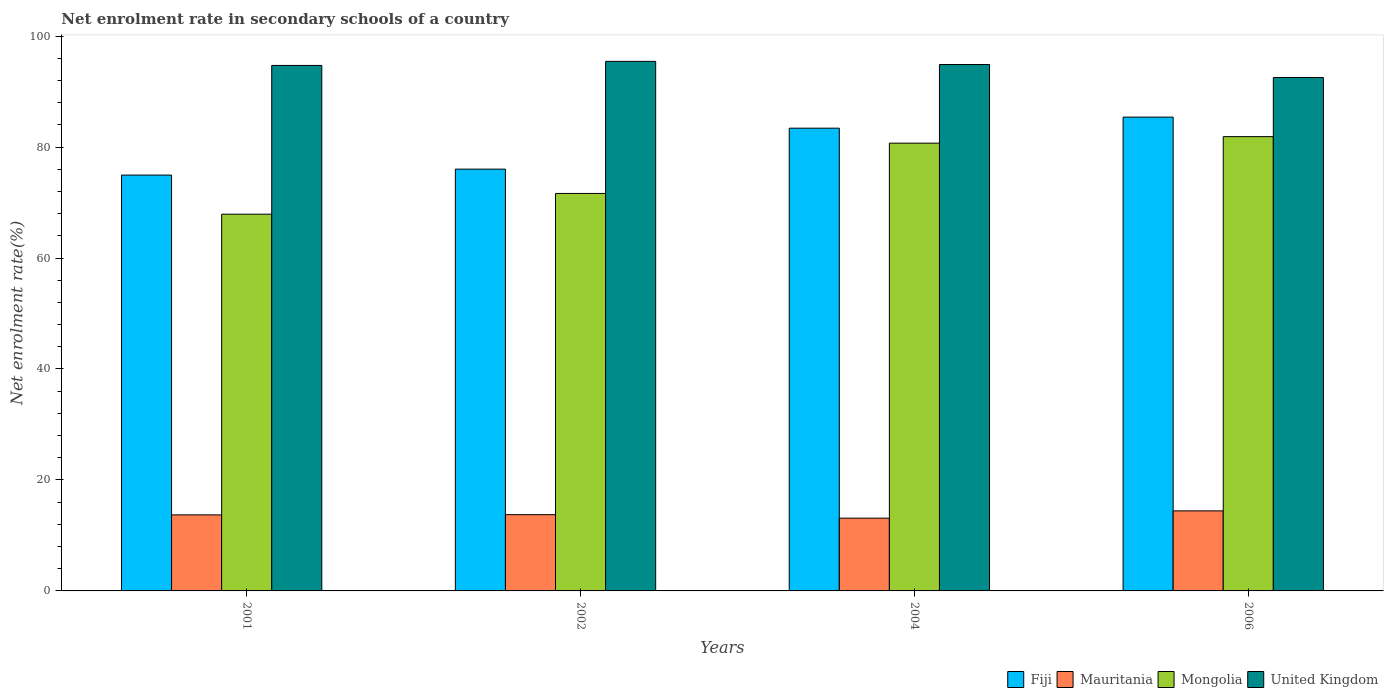How many different coloured bars are there?
Ensure brevity in your answer.  4. How many groups of bars are there?
Give a very brief answer. 4. Are the number of bars per tick equal to the number of legend labels?
Provide a short and direct response. Yes. Are the number of bars on each tick of the X-axis equal?
Provide a short and direct response. Yes. How many bars are there on the 1st tick from the left?
Your response must be concise. 4. How many bars are there on the 1st tick from the right?
Keep it short and to the point. 4. What is the label of the 3rd group of bars from the left?
Keep it short and to the point. 2004. In how many cases, is the number of bars for a given year not equal to the number of legend labels?
Give a very brief answer. 0. What is the net enrolment rate in secondary schools in Mauritania in 2002?
Your answer should be very brief. 13.75. Across all years, what is the maximum net enrolment rate in secondary schools in Mongolia?
Give a very brief answer. 81.88. Across all years, what is the minimum net enrolment rate in secondary schools in United Kingdom?
Ensure brevity in your answer.  92.54. In which year was the net enrolment rate in secondary schools in United Kingdom maximum?
Provide a succinct answer. 2002. What is the total net enrolment rate in secondary schools in Fiji in the graph?
Offer a very short reply. 319.78. What is the difference between the net enrolment rate in secondary schools in Mauritania in 2002 and that in 2006?
Give a very brief answer. -0.68. What is the difference between the net enrolment rate in secondary schools in Mongolia in 2006 and the net enrolment rate in secondary schools in Mauritania in 2004?
Offer a terse response. 68.77. What is the average net enrolment rate in secondary schools in Fiji per year?
Ensure brevity in your answer.  79.95. In the year 2001, what is the difference between the net enrolment rate in secondary schools in Mauritania and net enrolment rate in secondary schools in Mongolia?
Offer a terse response. -54.2. What is the ratio of the net enrolment rate in secondary schools in Fiji in 2001 to that in 2006?
Your answer should be very brief. 0.88. Is the net enrolment rate in secondary schools in Mauritania in 2004 less than that in 2006?
Make the answer very short. Yes. What is the difference between the highest and the second highest net enrolment rate in secondary schools in Fiji?
Make the answer very short. 1.99. What is the difference between the highest and the lowest net enrolment rate in secondary schools in United Kingdom?
Provide a short and direct response. 2.91. Is the sum of the net enrolment rate in secondary schools in Fiji in 2001 and 2006 greater than the maximum net enrolment rate in secondary schools in Mauritania across all years?
Keep it short and to the point. Yes. What does the 1st bar from the left in 2002 represents?
Offer a terse response. Fiji. What does the 3rd bar from the right in 2002 represents?
Ensure brevity in your answer.  Mauritania. Is it the case that in every year, the sum of the net enrolment rate in secondary schools in Mauritania and net enrolment rate in secondary schools in United Kingdom is greater than the net enrolment rate in secondary schools in Fiji?
Keep it short and to the point. Yes. How many bars are there?
Offer a very short reply. 16. Where does the legend appear in the graph?
Your response must be concise. Bottom right. How many legend labels are there?
Provide a succinct answer. 4. How are the legend labels stacked?
Keep it short and to the point. Horizontal. What is the title of the graph?
Provide a short and direct response. Net enrolment rate in secondary schools of a country. What is the label or title of the X-axis?
Keep it short and to the point. Years. What is the label or title of the Y-axis?
Provide a short and direct response. Net enrolment rate(%). What is the Net enrolment rate(%) of Fiji in 2001?
Offer a very short reply. 74.95. What is the Net enrolment rate(%) of Mauritania in 2001?
Provide a succinct answer. 13.71. What is the Net enrolment rate(%) in Mongolia in 2001?
Offer a very short reply. 67.9. What is the Net enrolment rate(%) of United Kingdom in 2001?
Your response must be concise. 94.72. What is the Net enrolment rate(%) of Fiji in 2002?
Your answer should be very brief. 76.02. What is the Net enrolment rate(%) in Mauritania in 2002?
Give a very brief answer. 13.75. What is the Net enrolment rate(%) in Mongolia in 2002?
Give a very brief answer. 71.64. What is the Net enrolment rate(%) in United Kingdom in 2002?
Keep it short and to the point. 95.45. What is the Net enrolment rate(%) of Fiji in 2004?
Offer a terse response. 83.41. What is the Net enrolment rate(%) of Mauritania in 2004?
Your answer should be compact. 13.11. What is the Net enrolment rate(%) in Mongolia in 2004?
Offer a very short reply. 80.71. What is the Net enrolment rate(%) of United Kingdom in 2004?
Keep it short and to the point. 94.88. What is the Net enrolment rate(%) in Fiji in 2006?
Your response must be concise. 85.4. What is the Net enrolment rate(%) in Mauritania in 2006?
Offer a very short reply. 14.43. What is the Net enrolment rate(%) in Mongolia in 2006?
Make the answer very short. 81.88. What is the Net enrolment rate(%) of United Kingdom in 2006?
Provide a short and direct response. 92.54. Across all years, what is the maximum Net enrolment rate(%) in Fiji?
Provide a short and direct response. 85.4. Across all years, what is the maximum Net enrolment rate(%) of Mauritania?
Offer a very short reply. 14.43. Across all years, what is the maximum Net enrolment rate(%) of Mongolia?
Give a very brief answer. 81.88. Across all years, what is the maximum Net enrolment rate(%) in United Kingdom?
Keep it short and to the point. 95.45. Across all years, what is the minimum Net enrolment rate(%) in Fiji?
Your response must be concise. 74.95. Across all years, what is the minimum Net enrolment rate(%) of Mauritania?
Offer a terse response. 13.11. Across all years, what is the minimum Net enrolment rate(%) in Mongolia?
Your answer should be very brief. 67.9. Across all years, what is the minimum Net enrolment rate(%) in United Kingdom?
Your response must be concise. 92.54. What is the total Net enrolment rate(%) in Fiji in the graph?
Offer a very short reply. 319.78. What is the total Net enrolment rate(%) in Mauritania in the graph?
Make the answer very short. 55. What is the total Net enrolment rate(%) of Mongolia in the graph?
Provide a short and direct response. 302.13. What is the total Net enrolment rate(%) in United Kingdom in the graph?
Give a very brief answer. 377.59. What is the difference between the Net enrolment rate(%) of Fiji in 2001 and that in 2002?
Offer a terse response. -1.07. What is the difference between the Net enrolment rate(%) in Mauritania in 2001 and that in 2002?
Provide a succinct answer. -0.04. What is the difference between the Net enrolment rate(%) in Mongolia in 2001 and that in 2002?
Ensure brevity in your answer.  -3.74. What is the difference between the Net enrolment rate(%) in United Kingdom in 2001 and that in 2002?
Your answer should be very brief. -0.73. What is the difference between the Net enrolment rate(%) of Fiji in 2001 and that in 2004?
Your answer should be compact. -8.46. What is the difference between the Net enrolment rate(%) in Mauritania in 2001 and that in 2004?
Offer a very short reply. 0.59. What is the difference between the Net enrolment rate(%) in Mongolia in 2001 and that in 2004?
Make the answer very short. -12.8. What is the difference between the Net enrolment rate(%) in United Kingdom in 2001 and that in 2004?
Provide a short and direct response. -0.17. What is the difference between the Net enrolment rate(%) in Fiji in 2001 and that in 2006?
Provide a short and direct response. -10.45. What is the difference between the Net enrolment rate(%) in Mauritania in 2001 and that in 2006?
Your answer should be compact. -0.72. What is the difference between the Net enrolment rate(%) in Mongolia in 2001 and that in 2006?
Provide a succinct answer. -13.98. What is the difference between the Net enrolment rate(%) of United Kingdom in 2001 and that in 2006?
Ensure brevity in your answer.  2.18. What is the difference between the Net enrolment rate(%) of Fiji in 2002 and that in 2004?
Offer a terse response. -7.38. What is the difference between the Net enrolment rate(%) in Mauritania in 2002 and that in 2004?
Your answer should be compact. 0.63. What is the difference between the Net enrolment rate(%) of Mongolia in 2002 and that in 2004?
Keep it short and to the point. -9.07. What is the difference between the Net enrolment rate(%) of United Kingdom in 2002 and that in 2004?
Provide a short and direct response. 0.57. What is the difference between the Net enrolment rate(%) of Fiji in 2002 and that in 2006?
Give a very brief answer. -9.38. What is the difference between the Net enrolment rate(%) of Mauritania in 2002 and that in 2006?
Make the answer very short. -0.68. What is the difference between the Net enrolment rate(%) in Mongolia in 2002 and that in 2006?
Keep it short and to the point. -10.24. What is the difference between the Net enrolment rate(%) in United Kingdom in 2002 and that in 2006?
Your response must be concise. 2.91. What is the difference between the Net enrolment rate(%) in Fiji in 2004 and that in 2006?
Ensure brevity in your answer.  -1.99. What is the difference between the Net enrolment rate(%) in Mauritania in 2004 and that in 2006?
Your response must be concise. -1.32. What is the difference between the Net enrolment rate(%) in Mongolia in 2004 and that in 2006?
Your response must be concise. -1.17. What is the difference between the Net enrolment rate(%) of United Kingdom in 2004 and that in 2006?
Offer a very short reply. 2.35. What is the difference between the Net enrolment rate(%) in Fiji in 2001 and the Net enrolment rate(%) in Mauritania in 2002?
Your response must be concise. 61.2. What is the difference between the Net enrolment rate(%) in Fiji in 2001 and the Net enrolment rate(%) in Mongolia in 2002?
Your answer should be very brief. 3.31. What is the difference between the Net enrolment rate(%) in Fiji in 2001 and the Net enrolment rate(%) in United Kingdom in 2002?
Give a very brief answer. -20.5. What is the difference between the Net enrolment rate(%) of Mauritania in 2001 and the Net enrolment rate(%) of Mongolia in 2002?
Ensure brevity in your answer.  -57.93. What is the difference between the Net enrolment rate(%) of Mauritania in 2001 and the Net enrolment rate(%) of United Kingdom in 2002?
Keep it short and to the point. -81.74. What is the difference between the Net enrolment rate(%) in Mongolia in 2001 and the Net enrolment rate(%) in United Kingdom in 2002?
Provide a short and direct response. -27.55. What is the difference between the Net enrolment rate(%) of Fiji in 2001 and the Net enrolment rate(%) of Mauritania in 2004?
Make the answer very short. 61.84. What is the difference between the Net enrolment rate(%) of Fiji in 2001 and the Net enrolment rate(%) of Mongolia in 2004?
Provide a short and direct response. -5.76. What is the difference between the Net enrolment rate(%) of Fiji in 2001 and the Net enrolment rate(%) of United Kingdom in 2004?
Your answer should be very brief. -19.93. What is the difference between the Net enrolment rate(%) of Mauritania in 2001 and the Net enrolment rate(%) of Mongolia in 2004?
Your response must be concise. -67. What is the difference between the Net enrolment rate(%) of Mauritania in 2001 and the Net enrolment rate(%) of United Kingdom in 2004?
Keep it short and to the point. -81.18. What is the difference between the Net enrolment rate(%) in Mongolia in 2001 and the Net enrolment rate(%) in United Kingdom in 2004?
Your answer should be very brief. -26.98. What is the difference between the Net enrolment rate(%) of Fiji in 2001 and the Net enrolment rate(%) of Mauritania in 2006?
Your answer should be compact. 60.52. What is the difference between the Net enrolment rate(%) of Fiji in 2001 and the Net enrolment rate(%) of Mongolia in 2006?
Offer a very short reply. -6.93. What is the difference between the Net enrolment rate(%) in Fiji in 2001 and the Net enrolment rate(%) in United Kingdom in 2006?
Your answer should be very brief. -17.59. What is the difference between the Net enrolment rate(%) of Mauritania in 2001 and the Net enrolment rate(%) of Mongolia in 2006?
Provide a short and direct response. -68.17. What is the difference between the Net enrolment rate(%) of Mauritania in 2001 and the Net enrolment rate(%) of United Kingdom in 2006?
Keep it short and to the point. -78.83. What is the difference between the Net enrolment rate(%) in Mongolia in 2001 and the Net enrolment rate(%) in United Kingdom in 2006?
Your answer should be compact. -24.63. What is the difference between the Net enrolment rate(%) of Fiji in 2002 and the Net enrolment rate(%) of Mauritania in 2004?
Give a very brief answer. 62.91. What is the difference between the Net enrolment rate(%) in Fiji in 2002 and the Net enrolment rate(%) in Mongolia in 2004?
Make the answer very short. -4.68. What is the difference between the Net enrolment rate(%) of Fiji in 2002 and the Net enrolment rate(%) of United Kingdom in 2004?
Ensure brevity in your answer.  -18.86. What is the difference between the Net enrolment rate(%) of Mauritania in 2002 and the Net enrolment rate(%) of Mongolia in 2004?
Ensure brevity in your answer.  -66.96. What is the difference between the Net enrolment rate(%) of Mauritania in 2002 and the Net enrolment rate(%) of United Kingdom in 2004?
Provide a succinct answer. -81.14. What is the difference between the Net enrolment rate(%) in Mongolia in 2002 and the Net enrolment rate(%) in United Kingdom in 2004?
Offer a terse response. -23.24. What is the difference between the Net enrolment rate(%) in Fiji in 2002 and the Net enrolment rate(%) in Mauritania in 2006?
Make the answer very short. 61.59. What is the difference between the Net enrolment rate(%) of Fiji in 2002 and the Net enrolment rate(%) of Mongolia in 2006?
Your answer should be very brief. -5.86. What is the difference between the Net enrolment rate(%) of Fiji in 2002 and the Net enrolment rate(%) of United Kingdom in 2006?
Keep it short and to the point. -16.51. What is the difference between the Net enrolment rate(%) in Mauritania in 2002 and the Net enrolment rate(%) in Mongolia in 2006?
Your response must be concise. -68.13. What is the difference between the Net enrolment rate(%) in Mauritania in 2002 and the Net enrolment rate(%) in United Kingdom in 2006?
Offer a very short reply. -78.79. What is the difference between the Net enrolment rate(%) of Mongolia in 2002 and the Net enrolment rate(%) of United Kingdom in 2006?
Ensure brevity in your answer.  -20.9. What is the difference between the Net enrolment rate(%) in Fiji in 2004 and the Net enrolment rate(%) in Mauritania in 2006?
Provide a short and direct response. 68.98. What is the difference between the Net enrolment rate(%) of Fiji in 2004 and the Net enrolment rate(%) of Mongolia in 2006?
Provide a short and direct response. 1.53. What is the difference between the Net enrolment rate(%) of Fiji in 2004 and the Net enrolment rate(%) of United Kingdom in 2006?
Ensure brevity in your answer.  -9.13. What is the difference between the Net enrolment rate(%) in Mauritania in 2004 and the Net enrolment rate(%) in Mongolia in 2006?
Provide a succinct answer. -68.77. What is the difference between the Net enrolment rate(%) of Mauritania in 2004 and the Net enrolment rate(%) of United Kingdom in 2006?
Offer a terse response. -79.42. What is the difference between the Net enrolment rate(%) of Mongolia in 2004 and the Net enrolment rate(%) of United Kingdom in 2006?
Ensure brevity in your answer.  -11.83. What is the average Net enrolment rate(%) in Fiji per year?
Provide a succinct answer. 79.95. What is the average Net enrolment rate(%) of Mauritania per year?
Offer a terse response. 13.75. What is the average Net enrolment rate(%) of Mongolia per year?
Ensure brevity in your answer.  75.53. What is the average Net enrolment rate(%) of United Kingdom per year?
Offer a very short reply. 94.4. In the year 2001, what is the difference between the Net enrolment rate(%) of Fiji and Net enrolment rate(%) of Mauritania?
Keep it short and to the point. 61.24. In the year 2001, what is the difference between the Net enrolment rate(%) of Fiji and Net enrolment rate(%) of Mongolia?
Provide a short and direct response. 7.05. In the year 2001, what is the difference between the Net enrolment rate(%) in Fiji and Net enrolment rate(%) in United Kingdom?
Your answer should be compact. -19.77. In the year 2001, what is the difference between the Net enrolment rate(%) in Mauritania and Net enrolment rate(%) in Mongolia?
Your answer should be compact. -54.2. In the year 2001, what is the difference between the Net enrolment rate(%) of Mauritania and Net enrolment rate(%) of United Kingdom?
Ensure brevity in your answer.  -81.01. In the year 2001, what is the difference between the Net enrolment rate(%) of Mongolia and Net enrolment rate(%) of United Kingdom?
Offer a terse response. -26.81. In the year 2002, what is the difference between the Net enrolment rate(%) in Fiji and Net enrolment rate(%) in Mauritania?
Your response must be concise. 62.28. In the year 2002, what is the difference between the Net enrolment rate(%) in Fiji and Net enrolment rate(%) in Mongolia?
Keep it short and to the point. 4.38. In the year 2002, what is the difference between the Net enrolment rate(%) in Fiji and Net enrolment rate(%) in United Kingdom?
Offer a very short reply. -19.43. In the year 2002, what is the difference between the Net enrolment rate(%) in Mauritania and Net enrolment rate(%) in Mongolia?
Provide a succinct answer. -57.9. In the year 2002, what is the difference between the Net enrolment rate(%) in Mauritania and Net enrolment rate(%) in United Kingdom?
Your answer should be very brief. -81.7. In the year 2002, what is the difference between the Net enrolment rate(%) of Mongolia and Net enrolment rate(%) of United Kingdom?
Offer a terse response. -23.81. In the year 2004, what is the difference between the Net enrolment rate(%) in Fiji and Net enrolment rate(%) in Mauritania?
Offer a terse response. 70.29. In the year 2004, what is the difference between the Net enrolment rate(%) in Fiji and Net enrolment rate(%) in Mongolia?
Your answer should be very brief. 2.7. In the year 2004, what is the difference between the Net enrolment rate(%) in Fiji and Net enrolment rate(%) in United Kingdom?
Offer a terse response. -11.48. In the year 2004, what is the difference between the Net enrolment rate(%) in Mauritania and Net enrolment rate(%) in Mongolia?
Provide a succinct answer. -67.59. In the year 2004, what is the difference between the Net enrolment rate(%) in Mauritania and Net enrolment rate(%) in United Kingdom?
Provide a succinct answer. -81.77. In the year 2004, what is the difference between the Net enrolment rate(%) in Mongolia and Net enrolment rate(%) in United Kingdom?
Ensure brevity in your answer.  -14.18. In the year 2006, what is the difference between the Net enrolment rate(%) in Fiji and Net enrolment rate(%) in Mauritania?
Your answer should be very brief. 70.97. In the year 2006, what is the difference between the Net enrolment rate(%) in Fiji and Net enrolment rate(%) in Mongolia?
Your answer should be very brief. 3.52. In the year 2006, what is the difference between the Net enrolment rate(%) of Fiji and Net enrolment rate(%) of United Kingdom?
Your answer should be compact. -7.14. In the year 2006, what is the difference between the Net enrolment rate(%) in Mauritania and Net enrolment rate(%) in Mongolia?
Provide a succinct answer. -67.45. In the year 2006, what is the difference between the Net enrolment rate(%) in Mauritania and Net enrolment rate(%) in United Kingdom?
Keep it short and to the point. -78.11. In the year 2006, what is the difference between the Net enrolment rate(%) of Mongolia and Net enrolment rate(%) of United Kingdom?
Ensure brevity in your answer.  -10.66. What is the ratio of the Net enrolment rate(%) in Fiji in 2001 to that in 2002?
Keep it short and to the point. 0.99. What is the ratio of the Net enrolment rate(%) in Mongolia in 2001 to that in 2002?
Keep it short and to the point. 0.95. What is the ratio of the Net enrolment rate(%) of Fiji in 2001 to that in 2004?
Provide a succinct answer. 0.9. What is the ratio of the Net enrolment rate(%) of Mauritania in 2001 to that in 2004?
Give a very brief answer. 1.05. What is the ratio of the Net enrolment rate(%) in Mongolia in 2001 to that in 2004?
Your response must be concise. 0.84. What is the ratio of the Net enrolment rate(%) in United Kingdom in 2001 to that in 2004?
Provide a succinct answer. 1. What is the ratio of the Net enrolment rate(%) of Fiji in 2001 to that in 2006?
Give a very brief answer. 0.88. What is the ratio of the Net enrolment rate(%) in Mauritania in 2001 to that in 2006?
Your answer should be very brief. 0.95. What is the ratio of the Net enrolment rate(%) of Mongolia in 2001 to that in 2006?
Your response must be concise. 0.83. What is the ratio of the Net enrolment rate(%) in United Kingdom in 2001 to that in 2006?
Ensure brevity in your answer.  1.02. What is the ratio of the Net enrolment rate(%) in Fiji in 2002 to that in 2004?
Provide a short and direct response. 0.91. What is the ratio of the Net enrolment rate(%) of Mauritania in 2002 to that in 2004?
Give a very brief answer. 1.05. What is the ratio of the Net enrolment rate(%) in Mongolia in 2002 to that in 2004?
Offer a very short reply. 0.89. What is the ratio of the Net enrolment rate(%) in Fiji in 2002 to that in 2006?
Give a very brief answer. 0.89. What is the ratio of the Net enrolment rate(%) in Mauritania in 2002 to that in 2006?
Make the answer very short. 0.95. What is the ratio of the Net enrolment rate(%) of Mongolia in 2002 to that in 2006?
Make the answer very short. 0.87. What is the ratio of the Net enrolment rate(%) of United Kingdom in 2002 to that in 2006?
Ensure brevity in your answer.  1.03. What is the ratio of the Net enrolment rate(%) in Fiji in 2004 to that in 2006?
Offer a very short reply. 0.98. What is the ratio of the Net enrolment rate(%) in Mauritania in 2004 to that in 2006?
Make the answer very short. 0.91. What is the ratio of the Net enrolment rate(%) in Mongolia in 2004 to that in 2006?
Your answer should be very brief. 0.99. What is the ratio of the Net enrolment rate(%) in United Kingdom in 2004 to that in 2006?
Your response must be concise. 1.03. What is the difference between the highest and the second highest Net enrolment rate(%) in Fiji?
Make the answer very short. 1.99. What is the difference between the highest and the second highest Net enrolment rate(%) of Mauritania?
Give a very brief answer. 0.68. What is the difference between the highest and the second highest Net enrolment rate(%) in Mongolia?
Your answer should be very brief. 1.17. What is the difference between the highest and the second highest Net enrolment rate(%) in United Kingdom?
Your answer should be compact. 0.57. What is the difference between the highest and the lowest Net enrolment rate(%) of Fiji?
Ensure brevity in your answer.  10.45. What is the difference between the highest and the lowest Net enrolment rate(%) of Mauritania?
Provide a short and direct response. 1.32. What is the difference between the highest and the lowest Net enrolment rate(%) of Mongolia?
Your answer should be compact. 13.98. What is the difference between the highest and the lowest Net enrolment rate(%) of United Kingdom?
Keep it short and to the point. 2.91. 